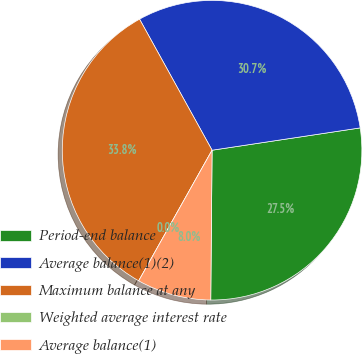Convert chart. <chart><loc_0><loc_0><loc_500><loc_500><pie_chart><fcel>Period-end balance<fcel>Average balance(1)(2)<fcel>Maximum balance at any<fcel>Weighted average interest rate<fcel>Average balance(1)<nl><fcel>27.52%<fcel>30.66%<fcel>33.81%<fcel>0.0%<fcel>8.0%<nl></chart> 